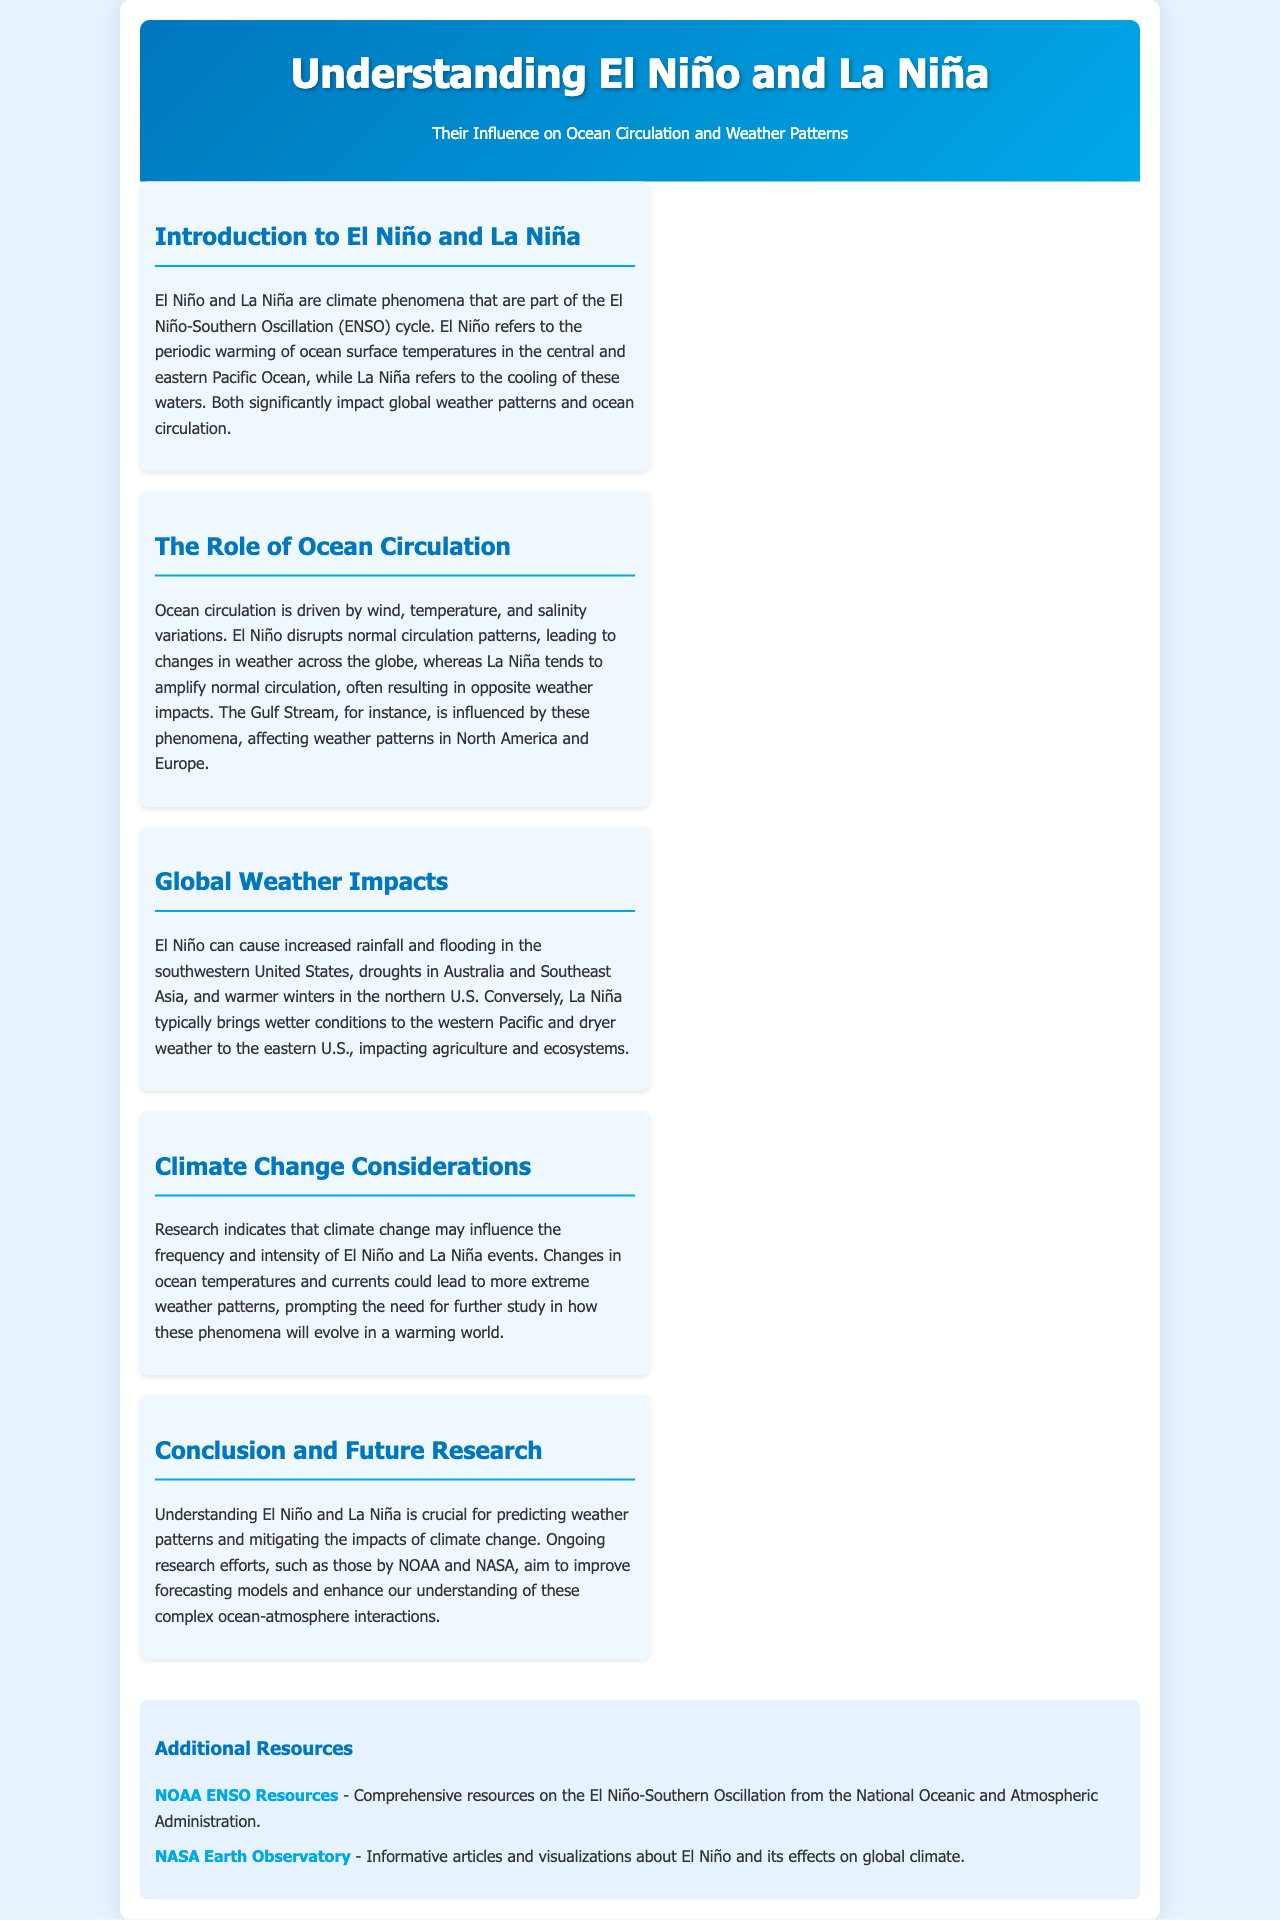What are El Niño and La Niña part of? Both phenomena are part of the El Niño-Southern Oscillation (ENSO) cycle.
Answer: El Niño-Southern Oscillation (ENSO) What does El Niño refer to? El Niño refers to the periodic warming of ocean surface temperatures in the central and eastern Pacific Ocean.
Answer: Warming of ocean surface temperatures What does La Niña refer to? La Niña refers to the cooling of ocean surface temperatures in the central and eastern Pacific Ocean.
Answer: Cooling of ocean surface temperatures How does El Niño affect rainfall in the southwestern United States? El Niño can cause increased rainfall in that region.
Answer: Increased rainfall What is the impact of La Niña on weather in the eastern U.S.? La Niña typically brings dryer weather to the eastern U.S.
Answer: Dryer weather What is a potential effect of climate change on El Niño and La Niña? Climate change may influence the frequency and intensity of these events.
Answer: Frequency and intensity Which two organizations are mentioned for ongoing research efforts? The document mentions NOAA and NASA for research on weather patterns.
Answer: NOAA and NASA What is the background color of the brochure? The background color of the brochure is light blue.
Answer: Light blue 